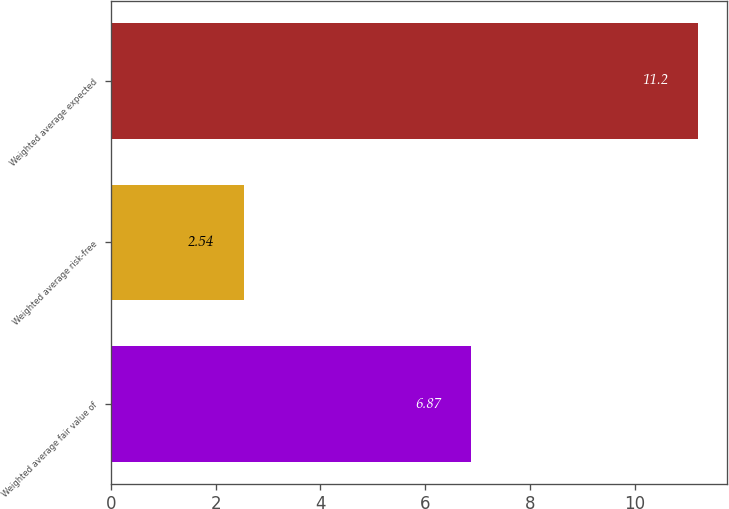Convert chart to OTSL. <chart><loc_0><loc_0><loc_500><loc_500><bar_chart><fcel>Weighted average fair value of<fcel>Weighted average risk-free<fcel>Weighted average expected<nl><fcel>6.87<fcel>2.54<fcel>11.2<nl></chart> 